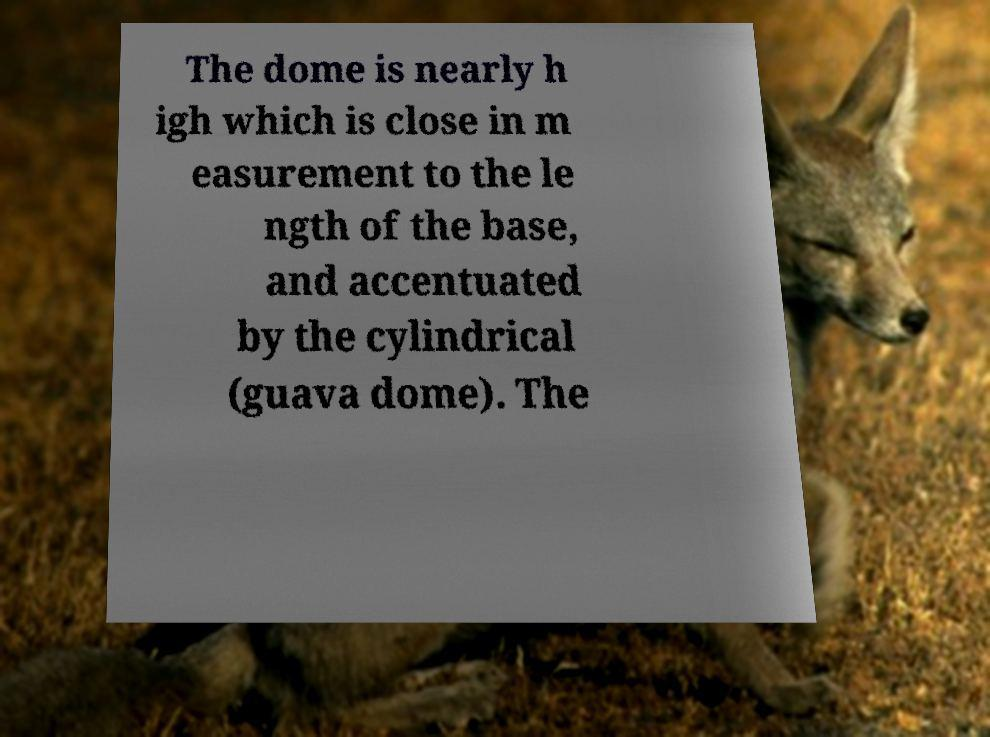What messages or text are displayed in this image? I need them in a readable, typed format. The dome is nearly h igh which is close in m easurement to the le ngth of the base, and accentuated by the cylindrical (guava dome). The 